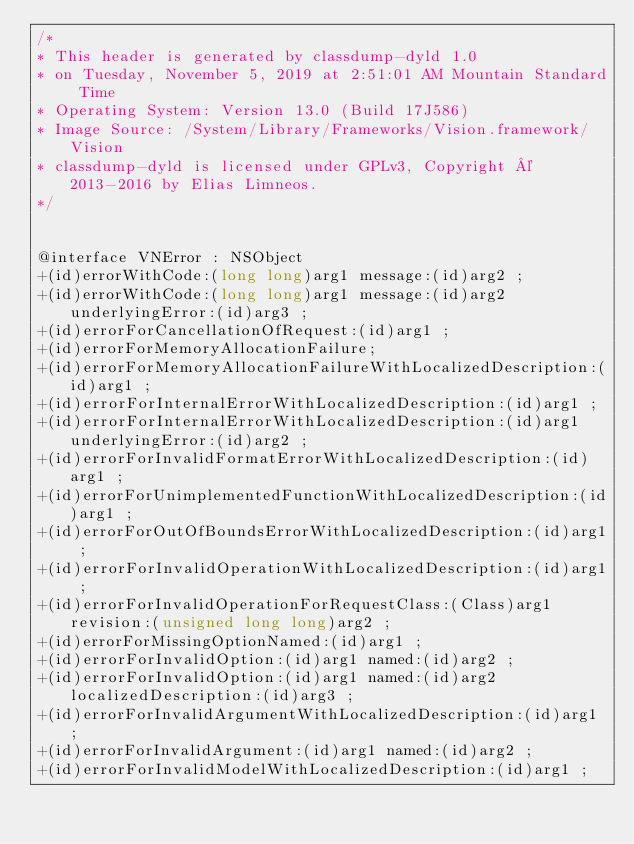<code> <loc_0><loc_0><loc_500><loc_500><_C_>/*
* This header is generated by classdump-dyld 1.0
* on Tuesday, November 5, 2019 at 2:51:01 AM Mountain Standard Time
* Operating System: Version 13.0 (Build 17J586)
* Image Source: /System/Library/Frameworks/Vision.framework/Vision
* classdump-dyld is licensed under GPLv3, Copyright © 2013-2016 by Elias Limneos.
*/


@interface VNError : NSObject
+(id)errorWithCode:(long long)arg1 message:(id)arg2 ;
+(id)errorWithCode:(long long)arg1 message:(id)arg2 underlyingError:(id)arg3 ;
+(id)errorForCancellationOfRequest:(id)arg1 ;
+(id)errorForMemoryAllocationFailure;
+(id)errorForMemoryAllocationFailureWithLocalizedDescription:(id)arg1 ;
+(id)errorForInternalErrorWithLocalizedDescription:(id)arg1 ;
+(id)errorForInternalErrorWithLocalizedDescription:(id)arg1 underlyingError:(id)arg2 ;
+(id)errorForInvalidFormatErrorWithLocalizedDescription:(id)arg1 ;
+(id)errorForUnimplementedFunctionWithLocalizedDescription:(id)arg1 ;
+(id)errorForOutOfBoundsErrorWithLocalizedDescription:(id)arg1 ;
+(id)errorForInvalidOperationWithLocalizedDescription:(id)arg1 ;
+(id)errorForInvalidOperationForRequestClass:(Class)arg1 revision:(unsigned long long)arg2 ;
+(id)errorForMissingOptionNamed:(id)arg1 ;
+(id)errorForInvalidOption:(id)arg1 named:(id)arg2 ;
+(id)errorForInvalidOption:(id)arg1 named:(id)arg2 localizedDescription:(id)arg3 ;
+(id)errorForInvalidArgumentWithLocalizedDescription:(id)arg1 ;
+(id)errorForInvalidArgument:(id)arg1 named:(id)arg2 ;
+(id)errorForInvalidModelWithLocalizedDescription:(id)arg1 ;</code> 